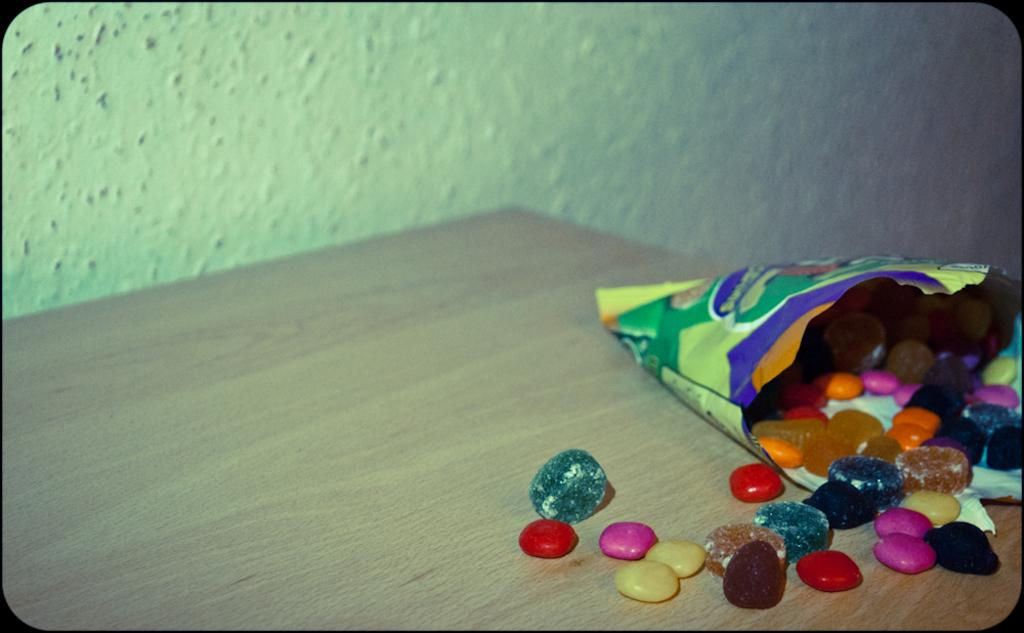What type of table is in the image? There is a wooden table in the image. What is placed on the wooden table? There is a packet with different color stones on the table. What type of agreement is being discussed in the image? There is no indication of an agreement being discussed in the image; it features a wooden table with a packet of different color stones. 